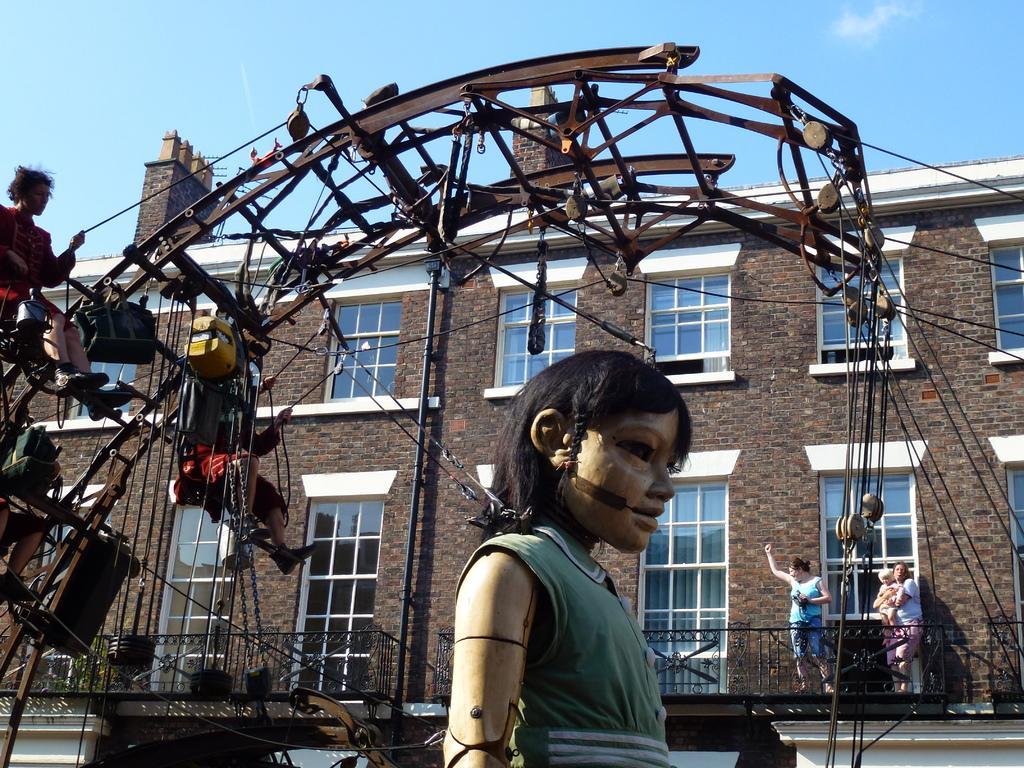How would you summarize this image in a sentence or two? In this image we can see that there is an arch like structure to which there are few people hanging with the ropes. In the background there is a building with the glass windows. At the bottom there is a statue. At the top there is the sky. 